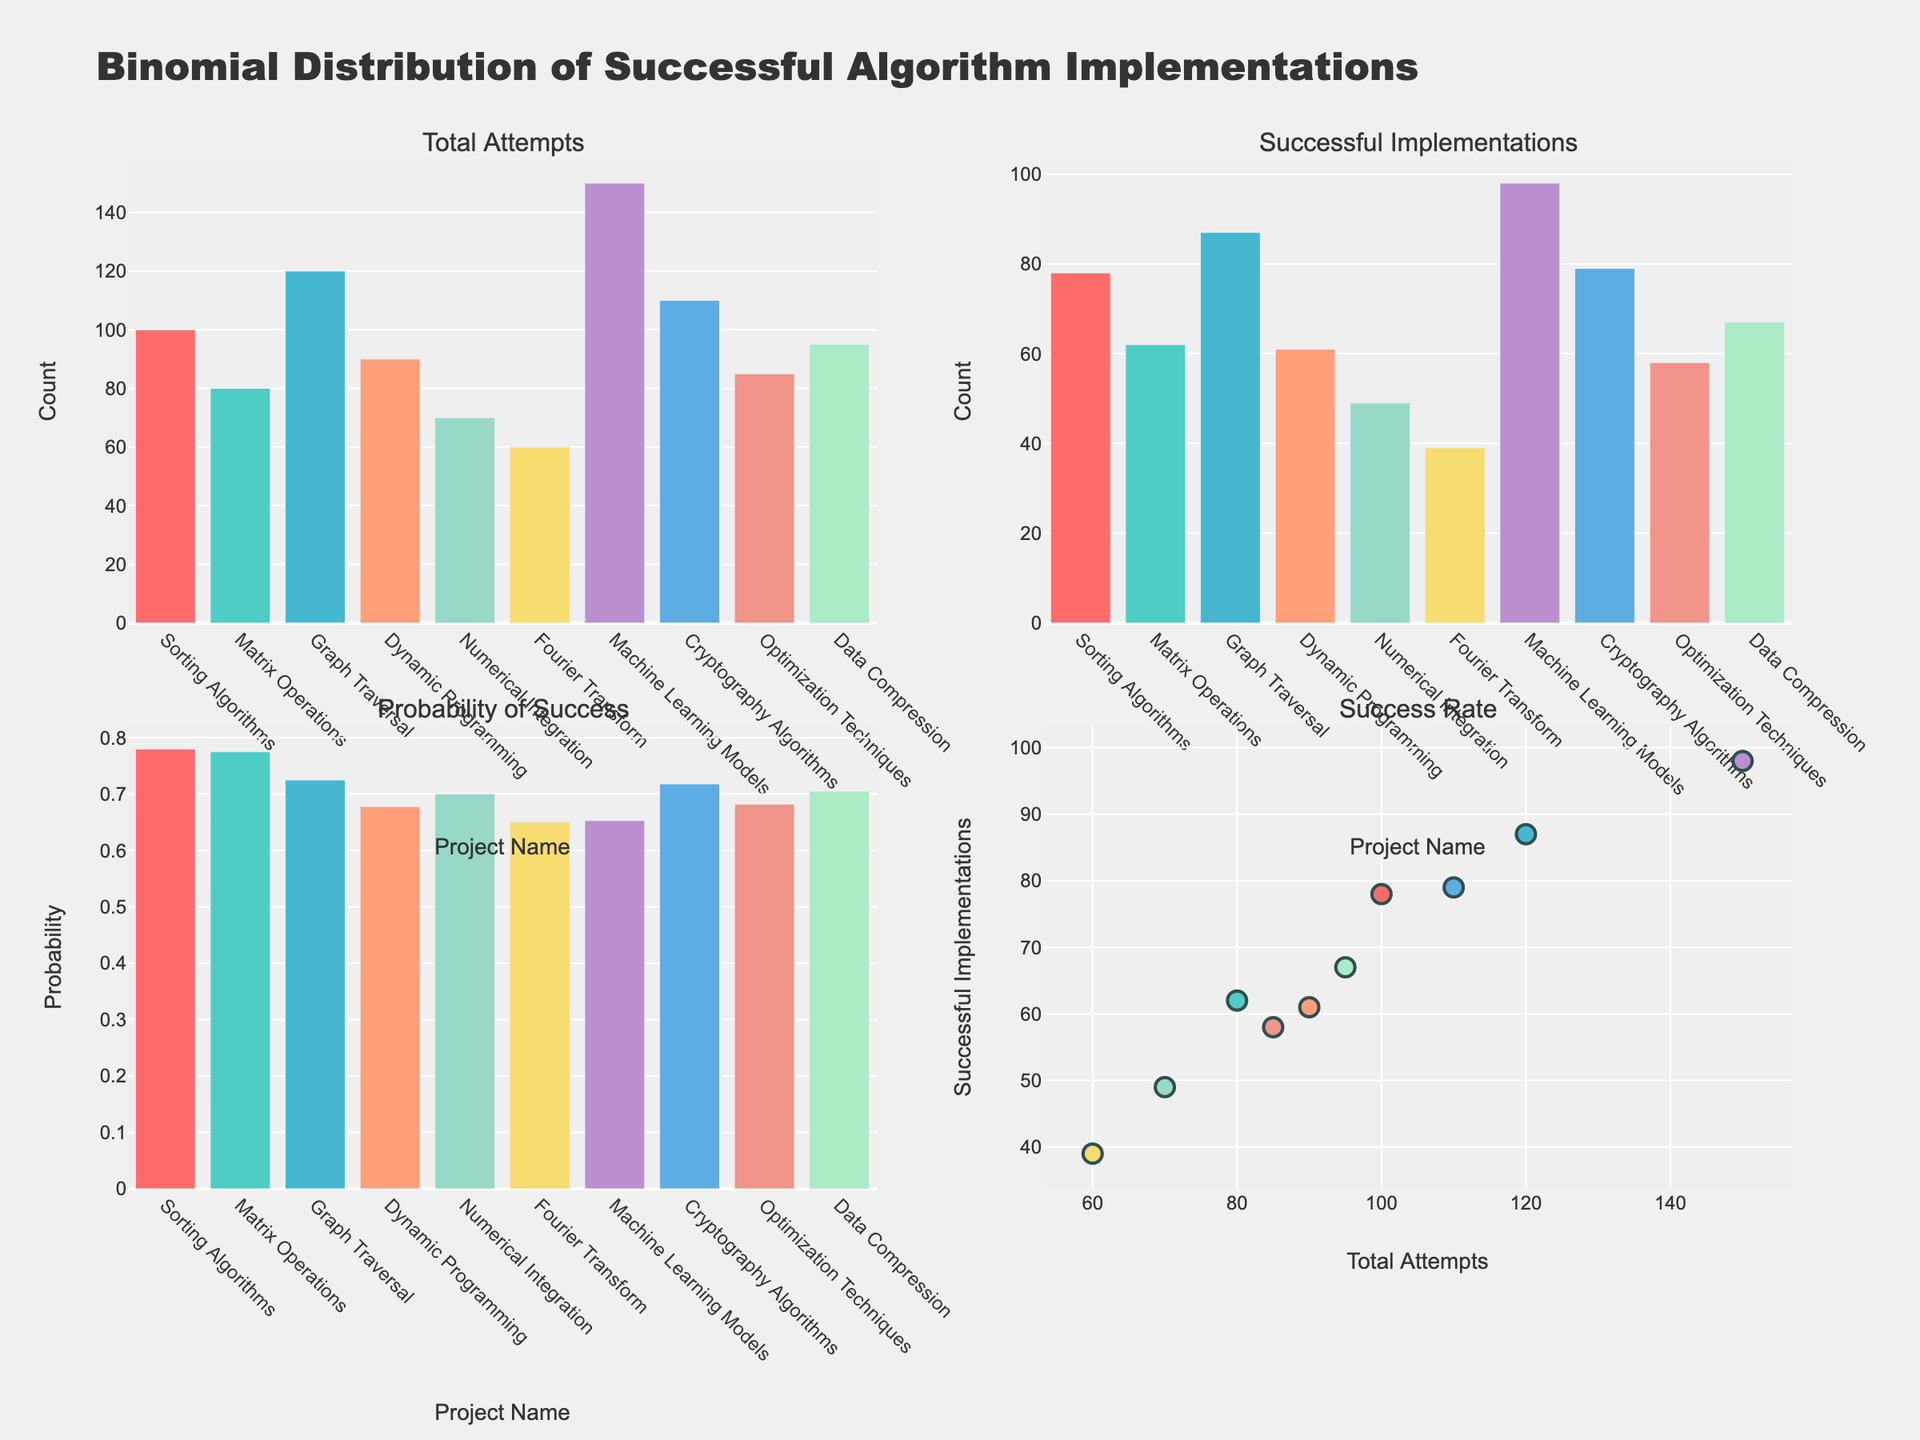what is the title of the figure? The title of the figure is displayed at the top and reads "Binomial Distribution of Successful Algorithm Implementations". This provides context for the data being visualized.
Answer: Binomial Distribution of Successful Algorithm Implementations How many total attempts did Sorting Algorithms have? The bars on the first subplot titled "Total Attempts" show the number of attempts for each project. The height of the bar for "Sorting Algorithms" corresponds to 100.
Answer: 100 What is the probability of success for Fourier Transform? The third subplot titled "Probability of Success" shows the probabilities for each project. The bar corresponding to "Fourier Transform" reaches up to 0.65.
Answer: 0.65 Which project has the highest number of successful implementations? The second subplot shows the number of successful implementations. The tallest bar represents "Machine Learning Models" with a height of 98.
Answer: Machine Learning Models Compare the total attempts of Sorting Algorithms and Graph Traversal. Which one has more attempts and by how much? Look at the "Total Attempts" subplot and compare the bar heights for Sorting Algorithms (100 attempts) and Graph Traversal (120 attempts). Graph Traversal has more attempts, by a difference of 120 - 100 = 20.
Answer: Graph Traversal, by 20 What is the average probability of success across all projects? To calculate this, sum the probabilities of success for all projects and divide by 10. The probabilities are 0.78, 0.775, 0.725, 0.678, 0.7, 0.65, 0.653, 0.718, 0.682, and 0.705. Sum = 7.086, Average = 7.086 / 10 = 0.7086.
Answer: 0.7086 Which project has the closest number of successful implementations to that of Matrix Operations? "Successful Implementations" subplot shows that Matrix Operations has 62 successful implementations; the next closest is Dynamic Programming with 61.
Answer: Dynamic Programming Compare the success rate of Matrix Operations and Cryptography Algorithms in the scatter plot. Which project has a higher success rate and by how much? In the scatter plot, the points for each project represent the total attempts on the x-axis and successful implementations on the y-axis. Matrix Operations has 80 attempts and 62 successful implementations (success rate = 62/80 = 0.775), and Cryptography Algorithms has 110 attempts and 79 successful implementations (success rate = 79/110 = 0.718). Difference = 0.775 - 0.718 = 0.057.
Answer: Matrix Operations, by 0.057 How many projects have a probability of success lower than 0.68? In the "Probability of Success" subplot, visually inspect the bars and count the ones lower than 0.68: Dynamic Programming, Fourier Transform, and Machine Learning Models, making a total of three.
Answer: 3 